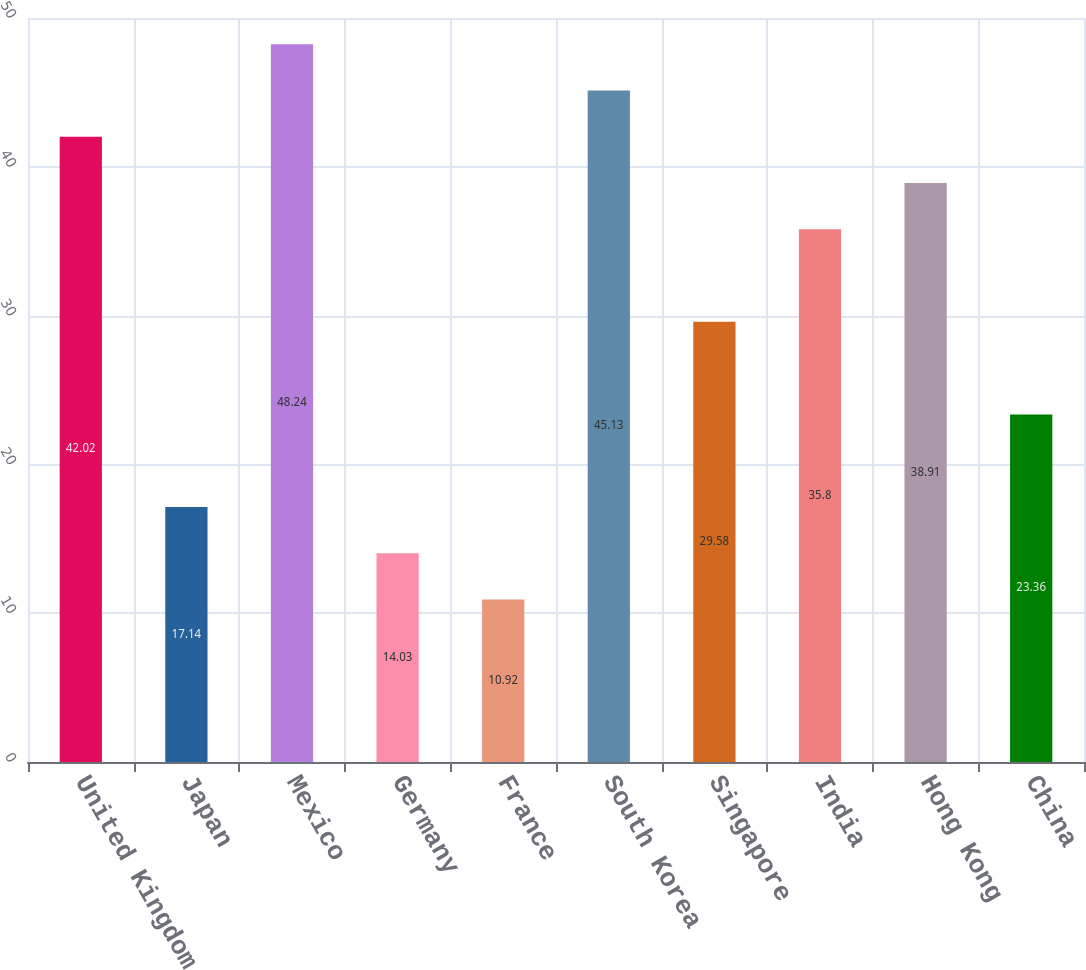Convert chart to OTSL. <chart><loc_0><loc_0><loc_500><loc_500><bar_chart><fcel>United Kingdom<fcel>Japan<fcel>Mexico<fcel>Germany<fcel>France<fcel>South Korea<fcel>Singapore<fcel>India<fcel>Hong Kong<fcel>China<nl><fcel>42.02<fcel>17.14<fcel>48.24<fcel>14.03<fcel>10.92<fcel>45.13<fcel>29.58<fcel>35.8<fcel>38.91<fcel>23.36<nl></chart> 